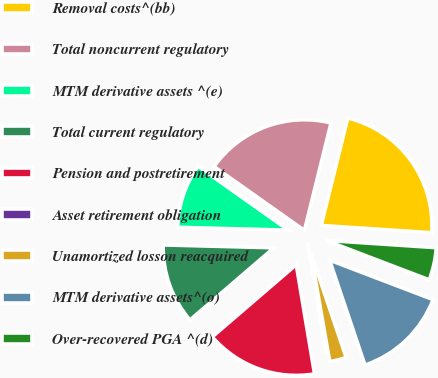Convert chart. <chart><loc_0><loc_0><loc_500><loc_500><pie_chart><fcel>Removal costs^(bb)<fcel>Total noncurrent regulatory<fcel>MTM derivative assets ^(e)<fcel>Total current regulatory<fcel>Pension and postretirement<fcel>Asset retirement obligation<fcel>Unamortized losson reacquired<fcel>MTM derivative assets^(o)<fcel>Over-recovered PGA ^(d)<nl><fcel>22.19%<fcel>19.06%<fcel>9.39%<fcel>11.71%<fcel>16.34%<fcel>0.11%<fcel>2.43%<fcel>14.02%<fcel>4.75%<nl></chart> 